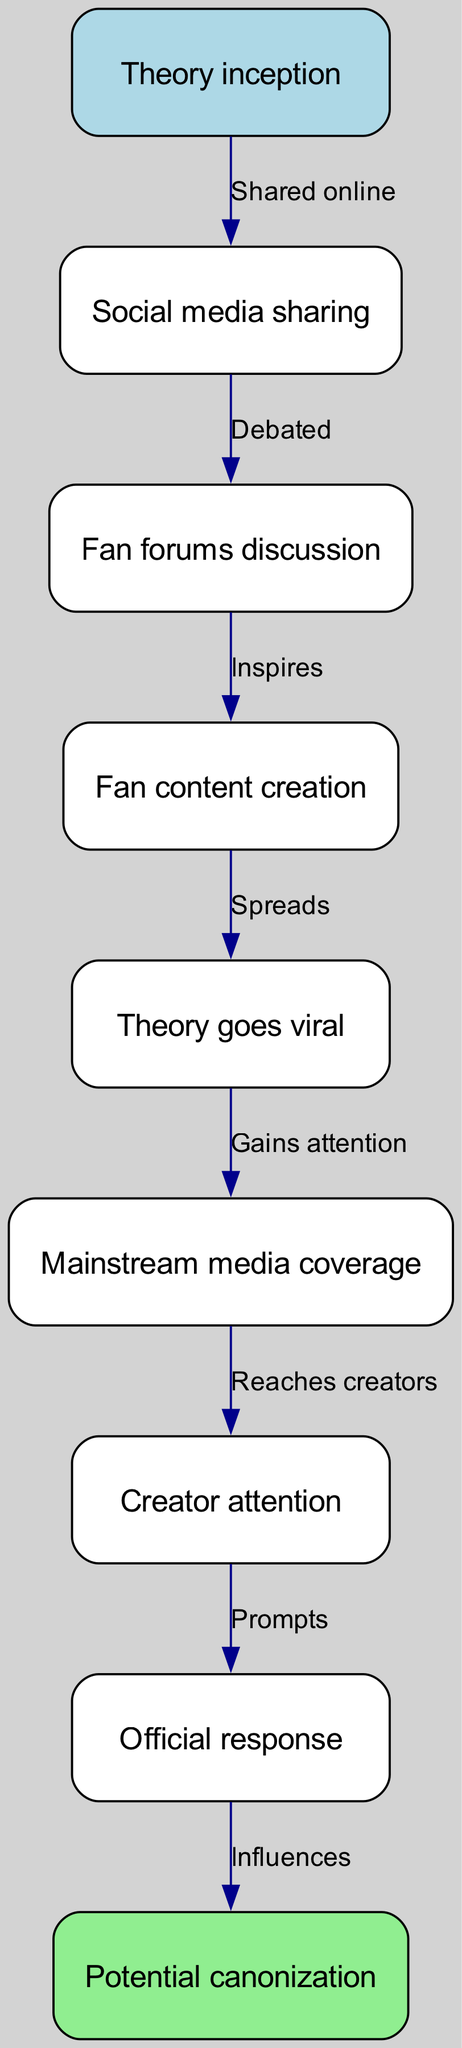What is the first stage of the fan theory lifecycle? The first stage is labeled "Theory inception," which indicates the starting point of a fan theory's development.
Answer: Theory inception How many nodes are present in the diagram? The diagram contains a total of 9 nodes, representing various stages in the lifecycle of a fan theory.
Answer: 9 What occurs after social media sharing? After social media sharing, the fan theory goes into "Fan forums discussion," where it is debated among fans.
Answer: Fan forums discussion Which node represents the step that involves creator acknowledgment? The node that represents the step involving creator acknowledgment is labeled "Creator attention." This indicates the moment when the original content creators become aware of the fan theory.
Answer: Creator attention How many edges connect to the "canonization" node? The "canonization" node has one edge connecting to it, coming from the "Official response" node, indicating that an official response influences its potential canonization.
Answer: 1 What process occurs after a fan theory goes viral? Following a fan theory going viral, it gains attention through "Mainstream media coverage," leading to broader discussion and awareness.
Answer: Mainstream media coverage Which two nodes represent the last stages before potential canonization? The last stages before potential canonization are represented by the nodes "Official response" and "canonization," indicating a direct progression toward canonization influenced by an official response.
Answer: Official response and canonization What type of content is created as a result of fan forums discussion? The type of content created after fan forums discussion is "Fan content creation," which emerges as fans express their interpretations and theories creatively.
Answer: Fan content creation Which edge represents the action of a theory gaining attention? The edge that represents the action of a theory gaining attention is labeled "Gains attention," which connects the "Viral" node to the "Mainstream media coverage" node.
Answer: Gains attention 